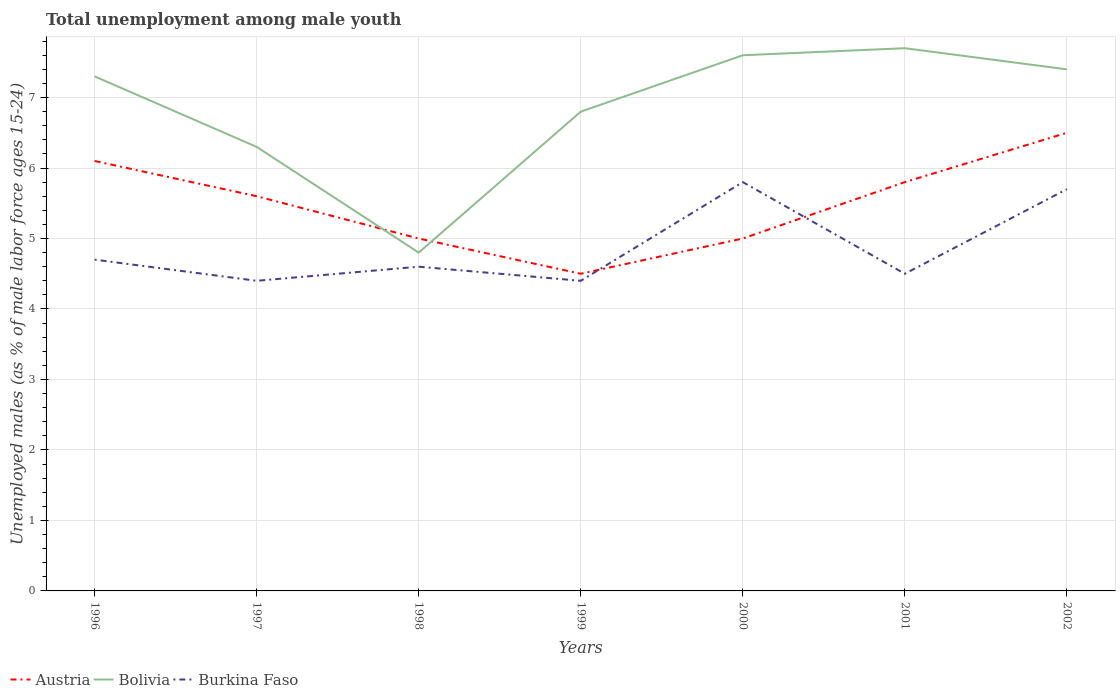How many different coloured lines are there?
Keep it short and to the point. 3. Does the line corresponding to Austria intersect with the line corresponding to Bolivia?
Provide a short and direct response. Yes. In which year was the percentage of unemployed males in in Burkina Faso maximum?
Provide a succinct answer. 1997. What is the total percentage of unemployed males in in Burkina Faso in the graph?
Your response must be concise. 0.3. What is the difference between the highest and the second highest percentage of unemployed males in in Bolivia?
Keep it short and to the point. 2.9. What is the difference between the highest and the lowest percentage of unemployed males in in Austria?
Your response must be concise. 4. Is the percentage of unemployed males in in Bolivia strictly greater than the percentage of unemployed males in in Austria over the years?
Give a very brief answer. No. How many lines are there?
Offer a terse response. 3. How many years are there in the graph?
Make the answer very short. 7. What is the difference between two consecutive major ticks on the Y-axis?
Your answer should be very brief. 1. Does the graph contain any zero values?
Offer a terse response. No. How many legend labels are there?
Provide a succinct answer. 3. What is the title of the graph?
Your answer should be compact. Total unemployment among male youth. What is the label or title of the X-axis?
Keep it short and to the point. Years. What is the label or title of the Y-axis?
Your answer should be compact. Unemployed males (as % of male labor force ages 15-24). What is the Unemployed males (as % of male labor force ages 15-24) in Austria in 1996?
Keep it short and to the point. 6.1. What is the Unemployed males (as % of male labor force ages 15-24) of Bolivia in 1996?
Your response must be concise. 7.3. What is the Unemployed males (as % of male labor force ages 15-24) in Burkina Faso in 1996?
Provide a succinct answer. 4.7. What is the Unemployed males (as % of male labor force ages 15-24) in Austria in 1997?
Ensure brevity in your answer.  5.6. What is the Unemployed males (as % of male labor force ages 15-24) in Bolivia in 1997?
Your answer should be very brief. 6.3. What is the Unemployed males (as % of male labor force ages 15-24) of Burkina Faso in 1997?
Your answer should be compact. 4.4. What is the Unemployed males (as % of male labor force ages 15-24) in Austria in 1998?
Provide a succinct answer. 5. What is the Unemployed males (as % of male labor force ages 15-24) of Bolivia in 1998?
Your response must be concise. 4.8. What is the Unemployed males (as % of male labor force ages 15-24) in Burkina Faso in 1998?
Ensure brevity in your answer.  4.6. What is the Unemployed males (as % of male labor force ages 15-24) in Austria in 1999?
Keep it short and to the point. 4.5. What is the Unemployed males (as % of male labor force ages 15-24) in Bolivia in 1999?
Keep it short and to the point. 6.8. What is the Unemployed males (as % of male labor force ages 15-24) of Burkina Faso in 1999?
Provide a short and direct response. 4.4. What is the Unemployed males (as % of male labor force ages 15-24) of Austria in 2000?
Give a very brief answer. 5. What is the Unemployed males (as % of male labor force ages 15-24) of Bolivia in 2000?
Offer a very short reply. 7.6. What is the Unemployed males (as % of male labor force ages 15-24) of Burkina Faso in 2000?
Ensure brevity in your answer.  5.8. What is the Unemployed males (as % of male labor force ages 15-24) in Austria in 2001?
Keep it short and to the point. 5.8. What is the Unemployed males (as % of male labor force ages 15-24) of Bolivia in 2001?
Provide a short and direct response. 7.7. What is the Unemployed males (as % of male labor force ages 15-24) in Burkina Faso in 2001?
Offer a very short reply. 4.5. What is the Unemployed males (as % of male labor force ages 15-24) in Bolivia in 2002?
Offer a terse response. 7.4. What is the Unemployed males (as % of male labor force ages 15-24) of Burkina Faso in 2002?
Your answer should be compact. 5.7. Across all years, what is the maximum Unemployed males (as % of male labor force ages 15-24) of Bolivia?
Ensure brevity in your answer.  7.7. Across all years, what is the maximum Unemployed males (as % of male labor force ages 15-24) of Burkina Faso?
Make the answer very short. 5.8. Across all years, what is the minimum Unemployed males (as % of male labor force ages 15-24) of Bolivia?
Your answer should be compact. 4.8. Across all years, what is the minimum Unemployed males (as % of male labor force ages 15-24) in Burkina Faso?
Your answer should be very brief. 4.4. What is the total Unemployed males (as % of male labor force ages 15-24) of Austria in the graph?
Provide a succinct answer. 38.5. What is the total Unemployed males (as % of male labor force ages 15-24) in Bolivia in the graph?
Offer a very short reply. 47.9. What is the total Unemployed males (as % of male labor force ages 15-24) of Burkina Faso in the graph?
Keep it short and to the point. 34.1. What is the difference between the Unemployed males (as % of male labor force ages 15-24) of Austria in 1996 and that in 1997?
Ensure brevity in your answer.  0.5. What is the difference between the Unemployed males (as % of male labor force ages 15-24) in Bolivia in 1996 and that in 1997?
Provide a short and direct response. 1. What is the difference between the Unemployed males (as % of male labor force ages 15-24) in Austria in 1996 and that in 1998?
Provide a succinct answer. 1.1. What is the difference between the Unemployed males (as % of male labor force ages 15-24) of Austria in 1996 and that in 1999?
Your answer should be compact. 1.6. What is the difference between the Unemployed males (as % of male labor force ages 15-24) of Bolivia in 1996 and that in 1999?
Your answer should be very brief. 0.5. What is the difference between the Unemployed males (as % of male labor force ages 15-24) in Burkina Faso in 1996 and that in 1999?
Your response must be concise. 0.3. What is the difference between the Unemployed males (as % of male labor force ages 15-24) of Austria in 1996 and that in 2000?
Provide a short and direct response. 1.1. What is the difference between the Unemployed males (as % of male labor force ages 15-24) in Bolivia in 1996 and that in 2000?
Offer a very short reply. -0.3. What is the difference between the Unemployed males (as % of male labor force ages 15-24) of Bolivia in 1996 and that in 2001?
Give a very brief answer. -0.4. What is the difference between the Unemployed males (as % of male labor force ages 15-24) of Austria in 1996 and that in 2002?
Make the answer very short. -0.4. What is the difference between the Unemployed males (as % of male labor force ages 15-24) of Burkina Faso in 1996 and that in 2002?
Give a very brief answer. -1. What is the difference between the Unemployed males (as % of male labor force ages 15-24) of Austria in 1997 and that in 1999?
Offer a terse response. 1.1. What is the difference between the Unemployed males (as % of male labor force ages 15-24) in Bolivia in 1997 and that in 1999?
Offer a very short reply. -0.5. What is the difference between the Unemployed males (as % of male labor force ages 15-24) of Austria in 1997 and that in 2000?
Keep it short and to the point. 0.6. What is the difference between the Unemployed males (as % of male labor force ages 15-24) in Austria in 1997 and that in 2001?
Make the answer very short. -0.2. What is the difference between the Unemployed males (as % of male labor force ages 15-24) in Burkina Faso in 1997 and that in 2001?
Give a very brief answer. -0.1. What is the difference between the Unemployed males (as % of male labor force ages 15-24) of Bolivia in 1997 and that in 2002?
Offer a very short reply. -1.1. What is the difference between the Unemployed males (as % of male labor force ages 15-24) of Burkina Faso in 1997 and that in 2002?
Make the answer very short. -1.3. What is the difference between the Unemployed males (as % of male labor force ages 15-24) of Austria in 1998 and that in 1999?
Ensure brevity in your answer.  0.5. What is the difference between the Unemployed males (as % of male labor force ages 15-24) of Bolivia in 1998 and that in 1999?
Make the answer very short. -2. What is the difference between the Unemployed males (as % of male labor force ages 15-24) in Burkina Faso in 1998 and that in 1999?
Offer a terse response. 0.2. What is the difference between the Unemployed males (as % of male labor force ages 15-24) of Austria in 1998 and that in 2000?
Your answer should be compact. 0. What is the difference between the Unemployed males (as % of male labor force ages 15-24) in Burkina Faso in 1998 and that in 2000?
Your response must be concise. -1.2. What is the difference between the Unemployed males (as % of male labor force ages 15-24) of Bolivia in 1998 and that in 2001?
Your answer should be very brief. -2.9. What is the difference between the Unemployed males (as % of male labor force ages 15-24) of Burkina Faso in 1998 and that in 2001?
Your response must be concise. 0.1. What is the difference between the Unemployed males (as % of male labor force ages 15-24) in Austria in 1999 and that in 2000?
Ensure brevity in your answer.  -0.5. What is the difference between the Unemployed males (as % of male labor force ages 15-24) of Austria in 1999 and that in 2001?
Your answer should be compact. -1.3. What is the difference between the Unemployed males (as % of male labor force ages 15-24) in Burkina Faso in 1999 and that in 2001?
Make the answer very short. -0.1. What is the difference between the Unemployed males (as % of male labor force ages 15-24) in Austria in 1999 and that in 2002?
Ensure brevity in your answer.  -2. What is the difference between the Unemployed males (as % of male labor force ages 15-24) of Burkina Faso in 1999 and that in 2002?
Your answer should be compact. -1.3. What is the difference between the Unemployed males (as % of male labor force ages 15-24) of Bolivia in 2000 and that in 2001?
Provide a succinct answer. -0.1. What is the difference between the Unemployed males (as % of male labor force ages 15-24) of Burkina Faso in 2000 and that in 2001?
Your answer should be compact. 1.3. What is the difference between the Unemployed males (as % of male labor force ages 15-24) in Bolivia in 2000 and that in 2002?
Offer a very short reply. 0.2. What is the difference between the Unemployed males (as % of male labor force ages 15-24) in Austria in 2001 and that in 2002?
Your answer should be compact. -0.7. What is the difference between the Unemployed males (as % of male labor force ages 15-24) in Austria in 1996 and the Unemployed males (as % of male labor force ages 15-24) in Burkina Faso in 1997?
Offer a terse response. 1.7. What is the difference between the Unemployed males (as % of male labor force ages 15-24) of Austria in 1996 and the Unemployed males (as % of male labor force ages 15-24) of Bolivia in 1998?
Give a very brief answer. 1.3. What is the difference between the Unemployed males (as % of male labor force ages 15-24) of Bolivia in 1996 and the Unemployed males (as % of male labor force ages 15-24) of Burkina Faso in 1998?
Provide a short and direct response. 2.7. What is the difference between the Unemployed males (as % of male labor force ages 15-24) of Austria in 1996 and the Unemployed males (as % of male labor force ages 15-24) of Burkina Faso in 1999?
Provide a succinct answer. 1.7. What is the difference between the Unemployed males (as % of male labor force ages 15-24) of Austria in 1996 and the Unemployed males (as % of male labor force ages 15-24) of Burkina Faso in 2000?
Your response must be concise. 0.3. What is the difference between the Unemployed males (as % of male labor force ages 15-24) in Bolivia in 1996 and the Unemployed males (as % of male labor force ages 15-24) in Burkina Faso in 2000?
Your answer should be compact. 1.5. What is the difference between the Unemployed males (as % of male labor force ages 15-24) of Austria in 1996 and the Unemployed males (as % of male labor force ages 15-24) of Bolivia in 2001?
Ensure brevity in your answer.  -1.6. What is the difference between the Unemployed males (as % of male labor force ages 15-24) of Austria in 1996 and the Unemployed males (as % of male labor force ages 15-24) of Burkina Faso in 2002?
Provide a short and direct response. 0.4. What is the difference between the Unemployed males (as % of male labor force ages 15-24) in Bolivia in 1997 and the Unemployed males (as % of male labor force ages 15-24) in Burkina Faso in 1998?
Your answer should be compact. 1.7. What is the difference between the Unemployed males (as % of male labor force ages 15-24) of Austria in 1997 and the Unemployed males (as % of male labor force ages 15-24) of Burkina Faso in 1999?
Offer a very short reply. 1.2. What is the difference between the Unemployed males (as % of male labor force ages 15-24) of Bolivia in 1997 and the Unemployed males (as % of male labor force ages 15-24) of Burkina Faso in 1999?
Your answer should be very brief. 1.9. What is the difference between the Unemployed males (as % of male labor force ages 15-24) of Austria in 1997 and the Unemployed males (as % of male labor force ages 15-24) of Bolivia in 2000?
Offer a very short reply. -2. What is the difference between the Unemployed males (as % of male labor force ages 15-24) in Bolivia in 1997 and the Unemployed males (as % of male labor force ages 15-24) in Burkina Faso in 2000?
Offer a terse response. 0.5. What is the difference between the Unemployed males (as % of male labor force ages 15-24) of Austria in 1997 and the Unemployed males (as % of male labor force ages 15-24) of Burkina Faso in 2001?
Your answer should be very brief. 1.1. What is the difference between the Unemployed males (as % of male labor force ages 15-24) in Austria in 1997 and the Unemployed males (as % of male labor force ages 15-24) in Bolivia in 2002?
Ensure brevity in your answer.  -1.8. What is the difference between the Unemployed males (as % of male labor force ages 15-24) in Bolivia in 1998 and the Unemployed males (as % of male labor force ages 15-24) in Burkina Faso in 1999?
Offer a terse response. 0.4. What is the difference between the Unemployed males (as % of male labor force ages 15-24) of Austria in 1998 and the Unemployed males (as % of male labor force ages 15-24) of Bolivia in 2001?
Your answer should be very brief. -2.7. What is the difference between the Unemployed males (as % of male labor force ages 15-24) of Austria in 1998 and the Unemployed males (as % of male labor force ages 15-24) of Burkina Faso in 2001?
Keep it short and to the point. 0.5. What is the difference between the Unemployed males (as % of male labor force ages 15-24) in Bolivia in 1998 and the Unemployed males (as % of male labor force ages 15-24) in Burkina Faso in 2001?
Offer a terse response. 0.3. What is the difference between the Unemployed males (as % of male labor force ages 15-24) of Bolivia in 1998 and the Unemployed males (as % of male labor force ages 15-24) of Burkina Faso in 2002?
Make the answer very short. -0.9. What is the difference between the Unemployed males (as % of male labor force ages 15-24) in Austria in 1999 and the Unemployed males (as % of male labor force ages 15-24) in Bolivia in 2000?
Offer a very short reply. -3.1. What is the difference between the Unemployed males (as % of male labor force ages 15-24) of Bolivia in 1999 and the Unemployed males (as % of male labor force ages 15-24) of Burkina Faso in 2000?
Make the answer very short. 1. What is the difference between the Unemployed males (as % of male labor force ages 15-24) in Austria in 1999 and the Unemployed males (as % of male labor force ages 15-24) in Bolivia in 2001?
Make the answer very short. -3.2. What is the difference between the Unemployed males (as % of male labor force ages 15-24) in Austria in 1999 and the Unemployed males (as % of male labor force ages 15-24) in Burkina Faso in 2001?
Ensure brevity in your answer.  0. What is the difference between the Unemployed males (as % of male labor force ages 15-24) of Bolivia in 1999 and the Unemployed males (as % of male labor force ages 15-24) of Burkina Faso in 2001?
Make the answer very short. 2.3. What is the difference between the Unemployed males (as % of male labor force ages 15-24) of Austria in 2000 and the Unemployed males (as % of male labor force ages 15-24) of Bolivia in 2001?
Provide a short and direct response. -2.7. What is the difference between the Unemployed males (as % of male labor force ages 15-24) in Austria in 2000 and the Unemployed males (as % of male labor force ages 15-24) in Burkina Faso in 2001?
Keep it short and to the point. 0.5. What is the difference between the Unemployed males (as % of male labor force ages 15-24) in Austria in 2000 and the Unemployed males (as % of male labor force ages 15-24) in Burkina Faso in 2002?
Your response must be concise. -0.7. What is the difference between the Unemployed males (as % of male labor force ages 15-24) in Bolivia in 2000 and the Unemployed males (as % of male labor force ages 15-24) in Burkina Faso in 2002?
Your answer should be compact. 1.9. What is the difference between the Unemployed males (as % of male labor force ages 15-24) in Austria in 2001 and the Unemployed males (as % of male labor force ages 15-24) in Burkina Faso in 2002?
Offer a terse response. 0.1. What is the average Unemployed males (as % of male labor force ages 15-24) of Austria per year?
Ensure brevity in your answer.  5.5. What is the average Unemployed males (as % of male labor force ages 15-24) in Bolivia per year?
Your response must be concise. 6.84. What is the average Unemployed males (as % of male labor force ages 15-24) in Burkina Faso per year?
Give a very brief answer. 4.87. In the year 1996, what is the difference between the Unemployed males (as % of male labor force ages 15-24) in Austria and Unemployed males (as % of male labor force ages 15-24) in Bolivia?
Keep it short and to the point. -1.2. In the year 1996, what is the difference between the Unemployed males (as % of male labor force ages 15-24) in Austria and Unemployed males (as % of male labor force ages 15-24) in Burkina Faso?
Keep it short and to the point. 1.4. In the year 1996, what is the difference between the Unemployed males (as % of male labor force ages 15-24) in Bolivia and Unemployed males (as % of male labor force ages 15-24) in Burkina Faso?
Your answer should be compact. 2.6. In the year 1997, what is the difference between the Unemployed males (as % of male labor force ages 15-24) in Austria and Unemployed males (as % of male labor force ages 15-24) in Bolivia?
Your response must be concise. -0.7. In the year 1998, what is the difference between the Unemployed males (as % of male labor force ages 15-24) of Austria and Unemployed males (as % of male labor force ages 15-24) of Bolivia?
Provide a short and direct response. 0.2. In the year 1998, what is the difference between the Unemployed males (as % of male labor force ages 15-24) in Bolivia and Unemployed males (as % of male labor force ages 15-24) in Burkina Faso?
Ensure brevity in your answer.  0.2. In the year 1999, what is the difference between the Unemployed males (as % of male labor force ages 15-24) in Austria and Unemployed males (as % of male labor force ages 15-24) in Bolivia?
Ensure brevity in your answer.  -2.3. In the year 1999, what is the difference between the Unemployed males (as % of male labor force ages 15-24) in Austria and Unemployed males (as % of male labor force ages 15-24) in Burkina Faso?
Your answer should be very brief. 0.1. In the year 2000, what is the difference between the Unemployed males (as % of male labor force ages 15-24) of Austria and Unemployed males (as % of male labor force ages 15-24) of Bolivia?
Your answer should be very brief. -2.6. In the year 2000, what is the difference between the Unemployed males (as % of male labor force ages 15-24) in Austria and Unemployed males (as % of male labor force ages 15-24) in Burkina Faso?
Ensure brevity in your answer.  -0.8. In the year 2001, what is the difference between the Unemployed males (as % of male labor force ages 15-24) of Austria and Unemployed males (as % of male labor force ages 15-24) of Burkina Faso?
Offer a terse response. 1.3. In the year 2001, what is the difference between the Unemployed males (as % of male labor force ages 15-24) in Bolivia and Unemployed males (as % of male labor force ages 15-24) in Burkina Faso?
Your answer should be compact. 3.2. In the year 2002, what is the difference between the Unemployed males (as % of male labor force ages 15-24) of Bolivia and Unemployed males (as % of male labor force ages 15-24) of Burkina Faso?
Offer a terse response. 1.7. What is the ratio of the Unemployed males (as % of male labor force ages 15-24) of Austria in 1996 to that in 1997?
Offer a very short reply. 1.09. What is the ratio of the Unemployed males (as % of male labor force ages 15-24) of Bolivia in 1996 to that in 1997?
Keep it short and to the point. 1.16. What is the ratio of the Unemployed males (as % of male labor force ages 15-24) of Burkina Faso in 1996 to that in 1997?
Give a very brief answer. 1.07. What is the ratio of the Unemployed males (as % of male labor force ages 15-24) in Austria in 1996 to that in 1998?
Ensure brevity in your answer.  1.22. What is the ratio of the Unemployed males (as % of male labor force ages 15-24) of Bolivia in 1996 to that in 1998?
Provide a short and direct response. 1.52. What is the ratio of the Unemployed males (as % of male labor force ages 15-24) of Burkina Faso in 1996 to that in 1998?
Make the answer very short. 1.02. What is the ratio of the Unemployed males (as % of male labor force ages 15-24) in Austria in 1996 to that in 1999?
Make the answer very short. 1.36. What is the ratio of the Unemployed males (as % of male labor force ages 15-24) in Bolivia in 1996 to that in 1999?
Keep it short and to the point. 1.07. What is the ratio of the Unemployed males (as % of male labor force ages 15-24) in Burkina Faso in 1996 to that in 1999?
Your answer should be very brief. 1.07. What is the ratio of the Unemployed males (as % of male labor force ages 15-24) in Austria in 1996 to that in 2000?
Your answer should be compact. 1.22. What is the ratio of the Unemployed males (as % of male labor force ages 15-24) of Bolivia in 1996 to that in 2000?
Ensure brevity in your answer.  0.96. What is the ratio of the Unemployed males (as % of male labor force ages 15-24) of Burkina Faso in 1996 to that in 2000?
Your answer should be very brief. 0.81. What is the ratio of the Unemployed males (as % of male labor force ages 15-24) in Austria in 1996 to that in 2001?
Make the answer very short. 1.05. What is the ratio of the Unemployed males (as % of male labor force ages 15-24) in Bolivia in 1996 to that in 2001?
Provide a short and direct response. 0.95. What is the ratio of the Unemployed males (as % of male labor force ages 15-24) of Burkina Faso in 1996 to that in 2001?
Give a very brief answer. 1.04. What is the ratio of the Unemployed males (as % of male labor force ages 15-24) in Austria in 1996 to that in 2002?
Make the answer very short. 0.94. What is the ratio of the Unemployed males (as % of male labor force ages 15-24) in Bolivia in 1996 to that in 2002?
Give a very brief answer. 0.99. What is the ratio of the Unemployed males (as % of male labor force ages 15-24) of Burkina Faso in 1996 to that in 2002?
Offer a very short reply. 0.82. What is the ratio of the Unemployed males (as % of male labor force ages 15-24) in Austria in 1997 to that in 1998?
Your answer should be very brief. 1.12. What is the ratio of the Unemployed males (as % of male labor force ages 15-24) in Bolivia in 1997 to that in 1998?
Ensure brevity in your answer.  1.31. What is the ratio of the Unemployed males (as % of male labor force ages 15-24) in Burkina Faso in 1997 to that in 1998?
Your answer should be very brief. 0.96. What is the ratio of the Unemployed males (as % of male labor force ages 15-24) in Austria in 1997 to that in 1999?
Offer a very short reply. 1.24. What is the ratio of the Unemployed males (as % of male labor force ages 15-24) in Bolivia in 1997 to that in 1999?
Your response must be concise. 0.93. What is the ratio of the Unemployed males (as % of male labor force ages 15-24) in Burkina Faso in 1997 to that in 1999?
Keep it short and to the point. 1. What is the ratio of the Unemployed males (as % of male labor force ages 15-24) in Austria in 1997 to that in 2000?
Provide a short and direct response. 1.12. What is the ratio of the Unemployed males (as % of male labor force ages 15-24) of Bolivia in 1997 to that in 2000?
Offer a terse response. 0.83. What is the ratio of the Unemployed males (as % of male labor force ages 15-24) of Burkina Faso in 1997 to that in 2000?
Your answer should be very brief. 0.76. What is the ratio of the Unemployed males (as % of male labor force ages 15-24) of Austria in 1997 to that in 2001?
Make the answer very short. 0.97. What is the ratio of the Unemployed males (as % of male labor force ages 15-24) of Bolivia in 1997 to that in 2001?
Provide a succinct answer. 0.82. What is the ratio of the Unemployed males (as % of male labor force ages 15-24) of Burkina Faso in 1997 to that in 2001?
Offer a very short reply. 0.98. What is the ratio of the Unemployed males (as % of male labor force ages 15-24) of Austria in 1997 to that in 2002?
Your answer should be very brief. 0.86. What is the ratio of the Unemployed males (as % of male labor force ages 15-24) in Bolivia in 1997 to that in 2002?
Offer a very short reply. 0.85. What is the ratio of the Unemployed males (as % of male labor force ages 15-24) of Burkina Faso in 1997 to that in 2002?
Make the answer very short. 0.77. What is the ratio of the Unemployed males (as % of male labor force ages 15-24) of Austria in 1998 to that in 1999?
Make the answer very short. 1.11. What is the ratio of the Unemployed males (as % of male labor force ages 15-24) in Bolivia in 1998 to that in 1999?
Make the answer very short. 0.71. What is the ratio of the Unemployed males (as % of male labor force ages 15-24) of Burkina Faso in 1998 to that in 1999?
Give a very brief answer. 1.05. What is the ratio of the Unemployed males (as % of male labor force ages 15-24) of Austria in 1998 to that in 2000?
Provide a succinct answer. 1. What is the ratio of the Unemployed males (as % of male labor force ages 15-24) in Bolivia in 1998 to that in 2000?
Make the answer very short. 0.63. What is the ratio of the Unemployed males (as % of male labor force ages 15-24) in Burkina Faso in 1998 to that in 2000?
Provide a short and direct response. 0.79. What is the ratio of the Unemployed males (as % of male labor force ages 15-24) of Austria in 1998 to that in 2001?
Offer a very short reply. 0.86. What is the ratio of the Unemployed males (as % of male labor force ages 15-24) in Bolivia in 1998 to that in 2001?
Give a very brief answer. 0.62. What is the ratio of the Unemployed males (as % of male labor force ages 15-24) in Burkina Faso in 1998 to that in 2001?
Make the answer very short. 1.02. What is the ratio of the Unemployed males (as % of male labor force ages 15-24) of Austria in 1998 to that in 2002?
Provide a succinct answer. 0.77. What is the ratio of the Unemployed males (as % of male labor force ages 15-24) of Bolivia in 1998 to that in 2002?
Your answer should be compact. 0.65. What is the ratio of the Unemployed males (as % of male labor force ages 15-24) of Burkina Faso in 1998 to that in 2002?
Keep it short and to the point. 0.81. What is the ratio of the Unemployed males (as % of male labor force ages 15-24) in Austria in 1999 to that in 2000?
Your answer should be compact. 0.9. What is the ratio of the Unemployed males (as % of male labor force ages 15-24) in Bolivia in 1999 to that in 2000?
Keep it short and to the point. 0.89. What is the ratio of the Unemployed males (as % of male labor force ages 15-24) of Burkina Faso in 1999 to that in 2000?
Provide a short and direct response. 0.76. What is the ratio of the Unemployed males (as % of male labor force ages 15-24) in Austria in 1999 to that in 2001?
Provide a succinct answer. 0.78. What is the ratio of the Unemployed males (as % of male labor force ages 15-24) in Bolivia in 1999 to that in 2001?
Offer a very short reply. 0.88. What is the ratio of the Unemployed males (as % of male labor force ages 15-24) in Burkina Faso in 1999 to that in 2001?
Your answer should be compact. 0.98. What is the ratio of the Unemployed males (as % of male labor force ages 15-24) in Austria in 1999 to that in 2002?
Offer a terse response. 0.69. What is the ratio of the Unemployed males (as % of male labor force ages 15-24) in Bolivia in 1999 to that in 2002?
Offer a very short reply. 0.92. What is the ratio of the Unemployed males (as % of male labor force ages 15-24) of Burkina Faso in 1999 to that in 2002?
Offer a terse response. 0.77. What is the ratio of the Unemployed males (as % of male labor force ages 15-24) of Austria in 2000 to that in 2001?
Ensure brevity in your answer.  0.86. What is the ratio of the Unemployed males (as % of male labor force ages 15-24) in Bolivia in 2000 to that in 2001?
Offer a very short reply. 0.99. What is the ratio of the Unemployed males (as % of male labor force ages 15-24) in Burkina Faso in 2000 to that in 2001?
Provide a short and direct response. 1.29. What is the ratio of the Unemployed males (as % of male labor force ages 15-24) of Austria in 2000 to that in 2002?
Give a very brief answer. 0.77. What is the ratio of the Unemployed males (as % of male labor force ages 15-24) of Bolivia in 2000 to that in 2002?
Your answer should be very brief. 1.03. What is the ratio of the Unemployed males (as % of male labor force ages 15-24) in Burkina Faso in 2000 to that in 2002?
Your answer should be very brief. 1.02. What is the ratio of the Unemployed males (as % of male labor force ages 15-24) of Austria in 2001 to that in 2002?
Ensure brevity in your answer.  0.89. What is the ratio of the Unemployed males (as % of male labor force ages 15-24) in Bolivia in 2001 to that in 2002?
Provide a succinct answer. 1.04. What is the ratio of the Unemployed males (as % of male labor force ages 15-24) in Burkina Faso in 2001 to that in 2002?
Offer a very short reply. 0.79. What is the difference between the highest and the second highest Unemployed males (as % of male labor force ages 15-24) in Burkina Faso?
Give a very brief answer. 0.1. What is the difference between the highest and the lowest Unemployed males (as % of male labor force ages 15-24) of Bolivia?
Your answer should be very brief. 2.9. What is the difference between the highest and the lowest Unemployed males (as % of male labor force ages 15-24) in Burkina Faso?
Ensure brevity in your answer.  1.4. 